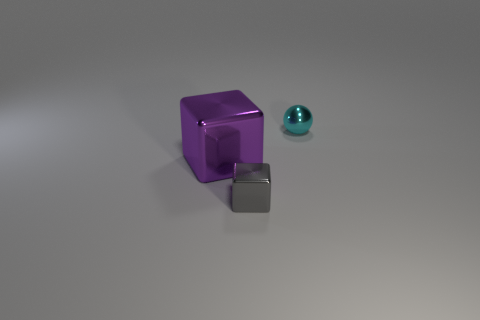What material is the small thing to the right of the tiny metal cube?
Ensure brevity in your answer.  Metal. Is the thing right of the gray cube made of the same material as the small block?
Keep it short and to the point. Yes. How many things are either large yellow things or tiny things that are behind the big metallic cube?
Provide a short and direct response. 1. There is another gray shiny thing that is the same shape as the big thing; what is its size?
Keep it short and to the point. Small. Is there anything else that has the same size as the gray block?
Your answer should be very brief. Yes. Are there any metal blocks behind the small cyan metallic object?
Keep it short and to the point. No. Does the small thing that is left of the small cyan object have the same color as the tiny metallic sphere behind the small gray block?
Offer a terse response. No. Is there a large purple metallic thing of the same shape as the tiny gray shiny thing?
Provide a succinct answer. Yes. There is a tiny thing that is on the right side of the tiny shiny object that is in front of the tiny thing behind the gray cube; what is its color?
Provide a succinct answer. Cyan. Is the number of tiny metal blocks that are on the right side of the gray block the same as the number of red things?
Give a very brief answer. Yes. 